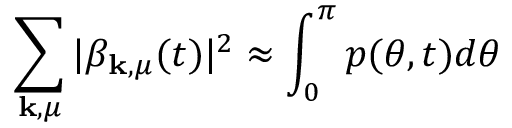Convert formula to latex. <formula><loc_0><loc_0><loc_500><loc_500>\sum _ { k , \mu } | \beta _ { k , \mu } ( t ) | ^ { 2 } \approx \int _ { 0 } ^ { \pi } p ( \theta , t ) d \theta</formula> 